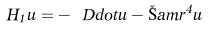<formula> <loc_0><loc_0><loc_500><loc_500>H _ { 1 } u = - \ D d o t u - \bar { \L } a m r ^ { 4 } u</formula> 